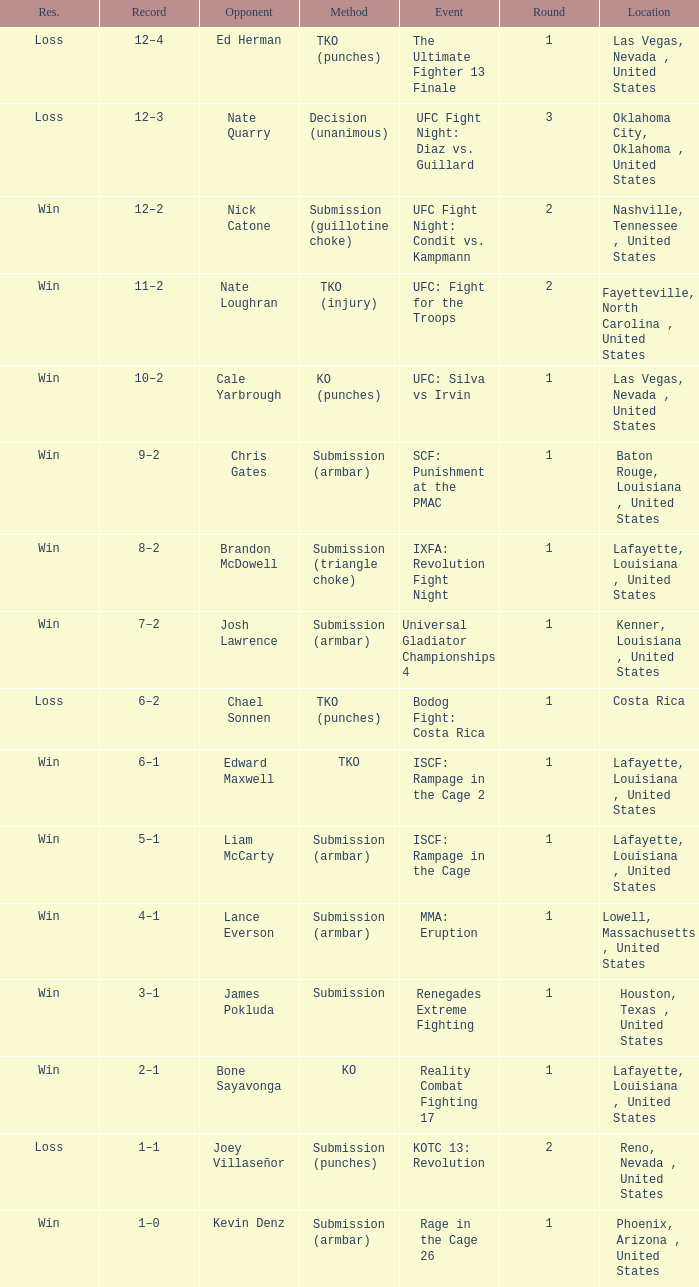What's was the location for fight against Liam Mccarty? Lafayette, Louisiana , United States. 